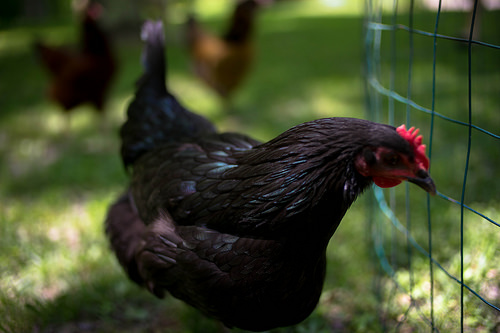<image>
Is the chicken on the chicken? No. The chicken is not positioned on the chicken. They may be near each other, but the chicken is not supported by or resting on top of the chicken. 